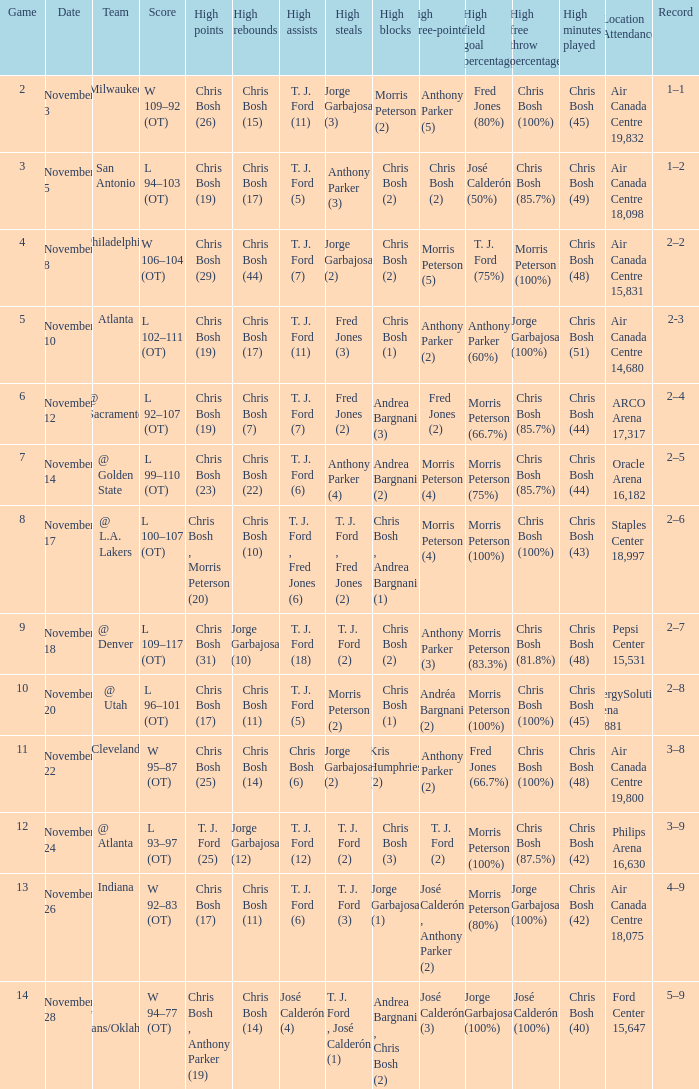Who had high assists when they played against San Antonio? T. J. Ford (5). 